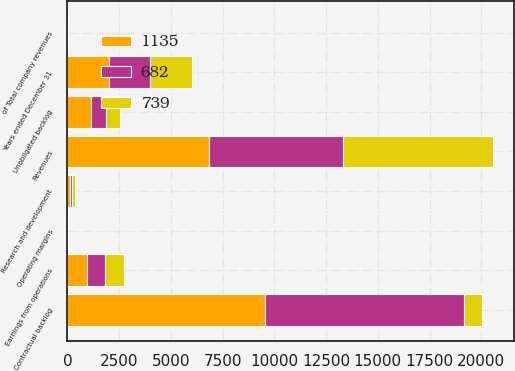<chart> <loc_0><loc_0><loc_500><loc_500><stacked_bar_chart><ecel><fcel>Years ended December 31<fcel>Revenues<fcel>of Total company revenues<fcel>Earnings from operations<fcel>Operating margins<fcel>Research and development<fcel>Contractual backlog<fcel>Unobligated backlog<nl><fcel>739<fcel>2008<fcel>7217<fcel>12<fcel>923<fcel>12.8<fcel>153<fcel>889<fcel>682<nl><fcel>1135<fcel>2007<fcel>6837<fcel>10<fcel>929<fcel>13.6<fcel>109<fcel>9537<fcel>1135<nl><fcel>682<fcel>2006<fcel>6502<fcel>11<fcel>889<fcel>13.7<fcel>102<fcel>9618<fcel>739<nl></chart> 